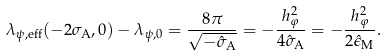Convert formula to latex. <formula><loc_0><loc_0><loc_500><loc_500>\lambda _ { \psi , \text {eff} } ( - 2 \sigma _ { \text {A} } , 0 ) - \lambda _ { \psi , 0 } = \frac { 8 \pi } { \sqrt { - \hat { \sigma } _ { \text {A} } } } = - \frac { h _ { \varphi } ^ { 2 } } { 4 \hat { \sigma } _ { \text {A} } } = - \frac { h _ { \varphi } ^ { 2 } } { 2 \hat { \epsilon } _ { \text {M} } } .</formula> 